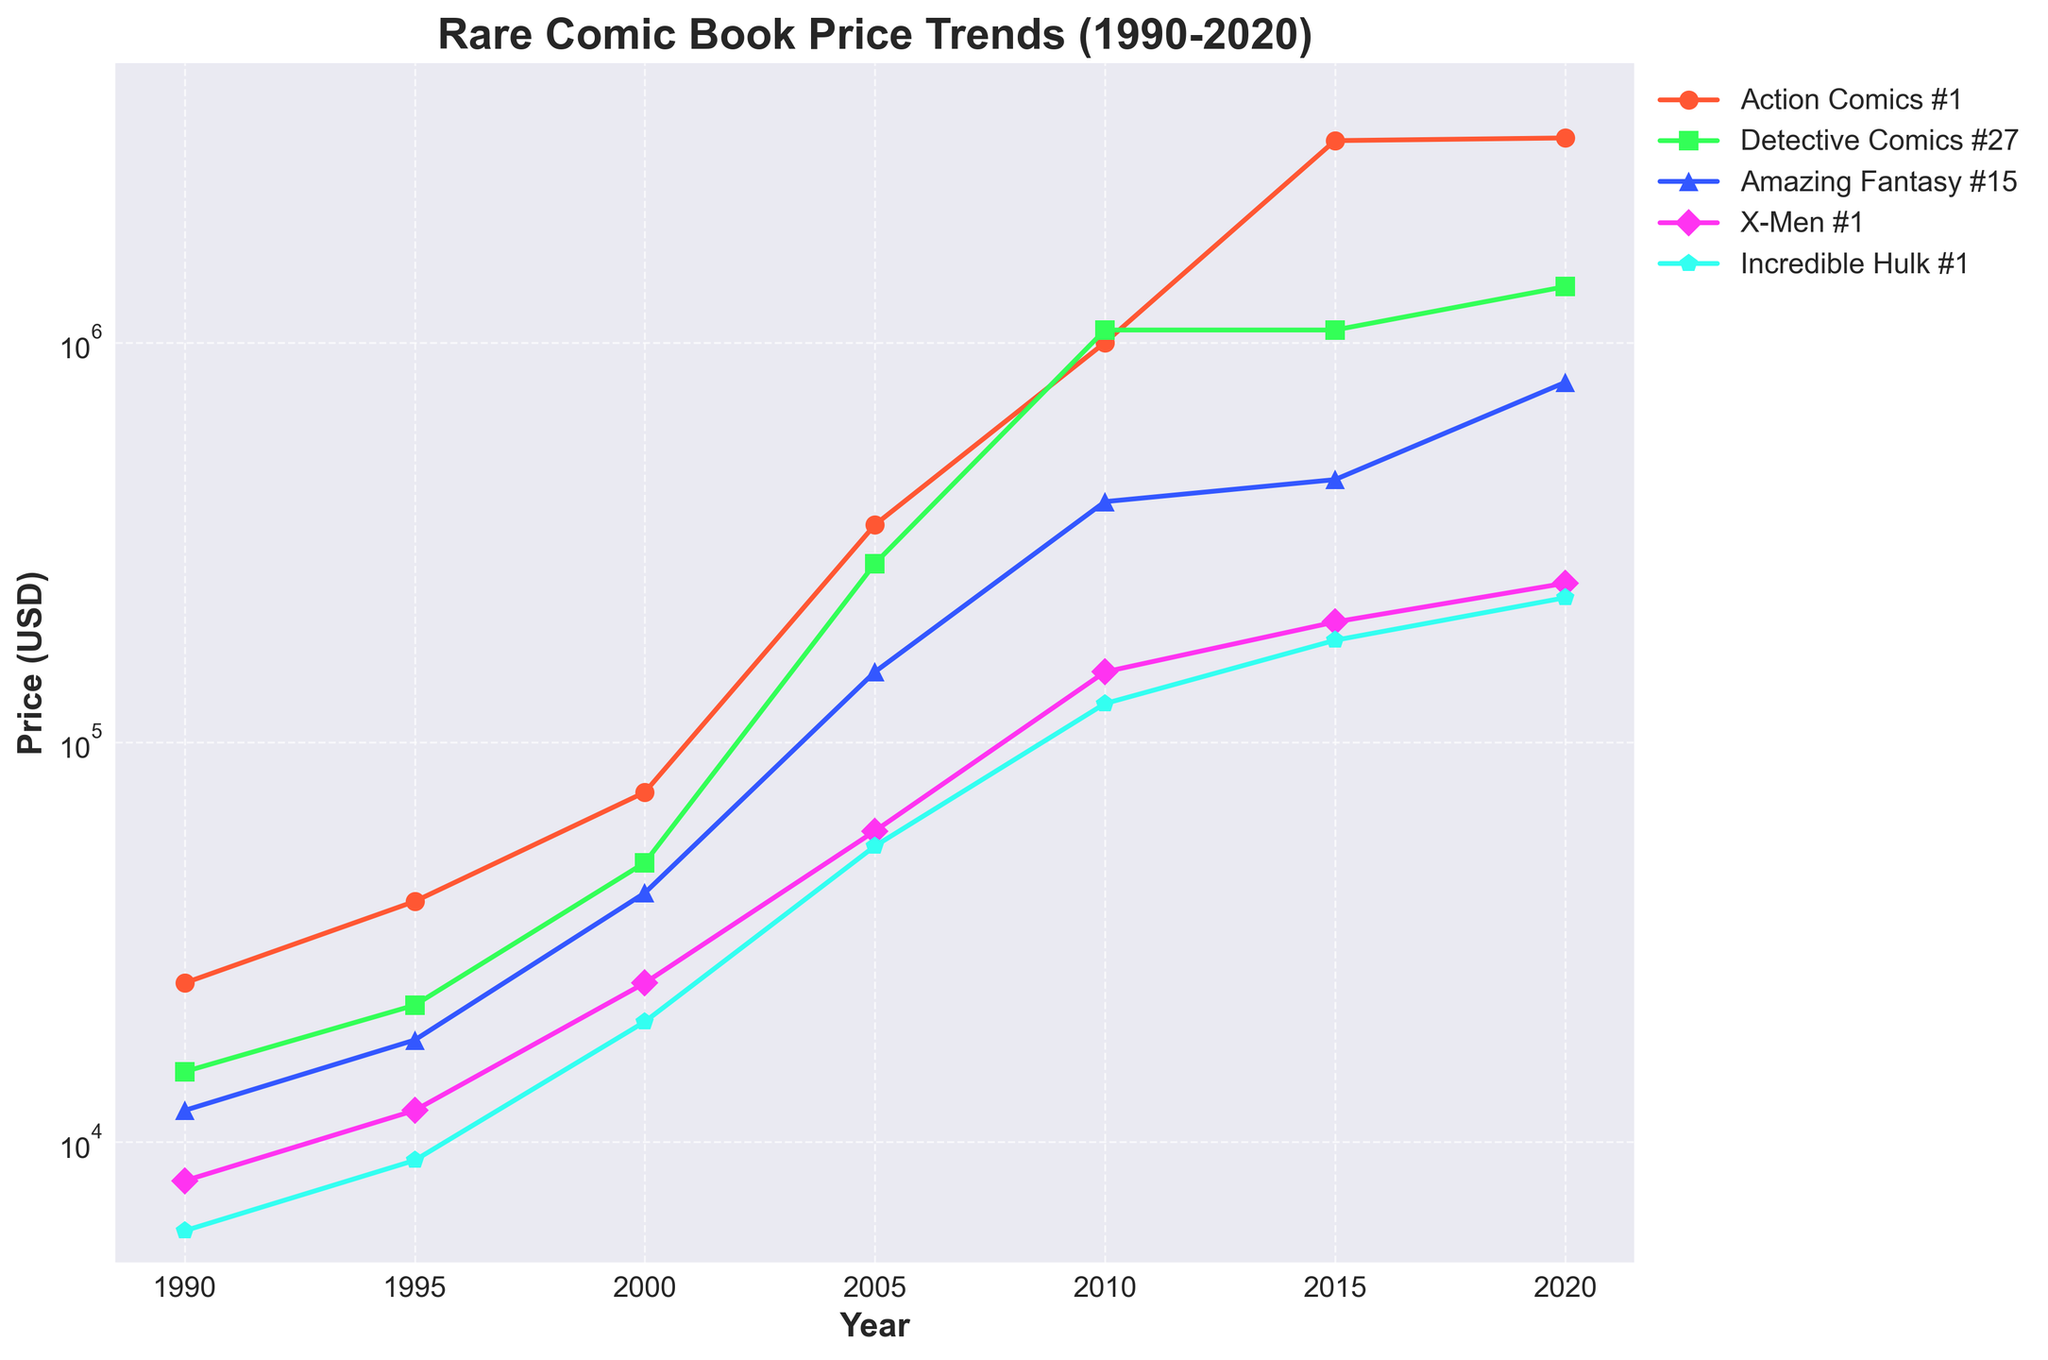What is the price difference between Action Comics #1 and Detective Comics #27 in 2020? To find the price difference, subtract the 2020 price of Detective Comics #27 from the 2020 price of Action Comics #1. Action Comics #1: $3,250,000, Detective Comics #27: $1,380,000. Therefore, $3,250,000 - $1,380,000 = $1,870,000
Answer: $1,870,000 Which comic experienced the largest price increase from 1990 to 2020? To find the largest price increase, calculate the difference in price from 1990 to 2020 for each comic and compare. Action Comics #1: $3,225,000, Detective Comics #27: $1,365,000, Amazing Fantasy #15: $783,000, X-Men #1: $242,000, Incredible Hulk #1: $224,000. The largest increase is $3,225,000 for Action Comics #1
Answer: Action Comics #1 What’s the average price of Amazing Fantasy #15 over the years 1990, 2000, and 2010? To find the average price, sum the prices for the years and divide by the number of years. Amazing Fantasy #15 in 1990: $12,000, 2000: $42,000, 2010: $400,000. Calculate the sum: $12,000 + $42,000 + $400,000 = $454,000. Then, divide by 3: $454,000 / 3 ≈ $151,333.33
Answer: About $151,333.33 What year witnessed a huge spike in the prices for X-Men #1? Observing the price trend of X-Men #1, there's a noticeable spike between 2000 and 2005 (from $25,000 to $60,000), but the most significant spike is between 2005 and 2010 from $60,000 to $150,000
Answer: Around 2010 Between Detective Comics #27 and Amazing Fantasy #15, which comic had higher prices in 2015 and by how much? Detective Comics #27 price in 2015 was $1,075,000, while Amazing Fantasy #15 was $454,100. The difference is $1,075,000 - $454,100 = $620,900. Therefore, Detective Comics #27 was higher by $620,900
Answer: Detective Comics #27 by $620,900 Which comic experienced no price change between any consecutive years shown? For each comic, compare consecutive years. All comics exhibit price changes over the years except for Detective Comics #27, which showed no change between 2010 and 2015
Answer: Detective Comics #27 between 2010 and 2015 